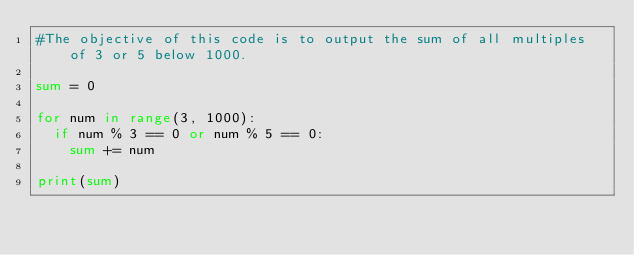<code> <loc_0><loc_0><loc_500><loc_500><_Python_>#The objective of this code is to output the sum of all multiples of 3 or 5 below 1000.

sum = 0

for num in range(3, 1000):
  if num % 3 == 0 or num % 5 == 0:
    sum += num

print(sum)
</code> 